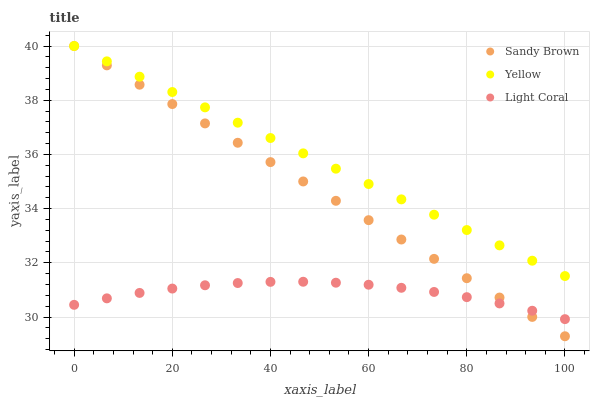Does Light Coral have the minimum area under the curve?
Answer yes or no. Yes. Does Yellow have the maximum area under the curve?
Answer yes or no. Yes. Does Sandy Brown have the minimum area under the curve?
Answer yes or no. No. Does Sandy Brown have the maximum area under the curve?
Answer yes or no. No. Is Sandy Brown the smoothest?
Answer yes or no. Yes. Is Light Coral the roughest?
Answer yes or no. Yes. Is Yellow the smoothest?
Answer yes or no. No. Is Yellow the roughest?
Answer yes or no. No. Does Sandy Brown have the lowest value?
Answer yes or no. Yes. Does Yellow have the lowest value?
Answer yes or no. No. Does Yellow have the highest value?
Answer yes or no. Yes. Is Light Coral less than Yellow?
Answer yes or no. Yes. Is Yellow greater than Light Coral?
Answer yes or no. Yes. Does Sandy Brown intersect Yellow?
Answer yes or no. Yes. Is Sandy Brown less than Yellow?
Answer yes or no. No. Is Sandy Brown greater than Yellow?
Answer yes or no. No. Does Light Coral intersect Yellow?
Answer yes or no. No. 